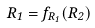<formula> <loc_0><loc_0><loc_500><loc_500>R _ { 1 } = f _ { R _ { 1 } } ( R _ { 2 } )</formula> 